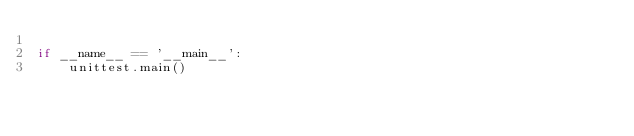Convert code to text. <code><loc_0><loc_0><loc_500><loc_500><_Python_>
if __name__ == '__main__':
    unittest.main()
</code> 